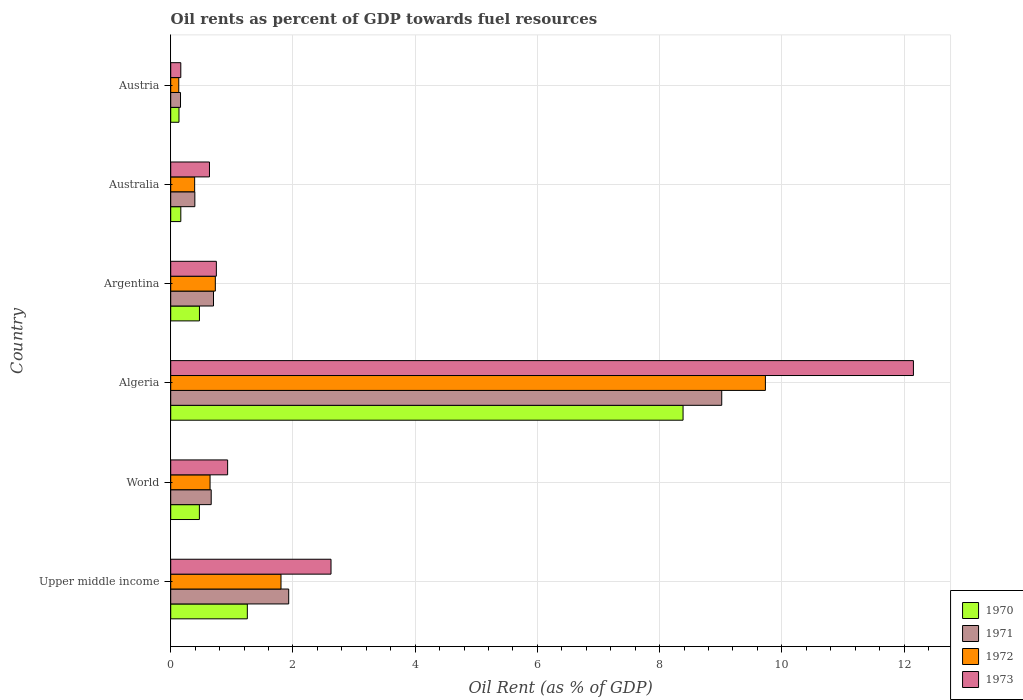Are the number of bars on each tick of the Y-axis equal?
Keep it short and to the point. Yes. How many bars are there on the 2nd tick from the top?
Give a very brief answer. 4. What is the oil rent in 1970 in Australia?
Make the answer very short. 0.17. Across all countries, what is the maximum oil rent in 1971?
Keep it short and to the point. 9.02. Across all countries, what is the minimum oil rent in 1970?
Make the answer very short. 0.14. In which country was the oil rent in 1972 maximum?
Provide a succinct answer. Algeria. What is the total oil rent in 1972 in the graph?
Keep it short and to the point. 13.43. What is the difference between the oil rent in 1972 in Australia and that in World?
Ensure brevity in your answer.  -0.25. What is the difference between the oil rent in 1973 in Upper middle income and the oil rent in 1970 in Algeria?
Make the answer very short. -5.76. What is the average oil rent in 1970 per country?
Provide a short and direct response. 1.81. What is the difference between the oil rent in 1972 and oil rent in 1971 in Upper middle income?
Provide a short and direct response. -0.13. What is the ratio of the oil rent in 1972 in Argentina to that in World?
Give a very brief answer. 1.13. Is the oil rent in 1971 in Algeria less than that in Austria?
Offer a terse response. No. Is the difference between the oil rent in 1972 in Austria and Upper middle income greater than the difference between the oil rent in 1971 in Austria and Upper middle income?
Give a very brief answer. Yes. What is the difference between the highest and the second highest oil rent in 1970?
Offer a terse response. 7.13. What is the difference between the highest and the lowest oil rent in 1970?
Offer a terse response. 8.25. In how many countries, is the oil rent in 1973 greater than the average oil rent in 1973 taken over all countries?
Ensure brevity in your answer.  1. What does the 3rd bar from the top in Australia represents?
Provide a succinct answer. 1971. What does the 1st bar from the bottom in Argentina represents?
Give a very brief answer. 1970. How many bars are there?
Keep it short and to the point. 24. How many countries are there in the graph?
Make the answer very short. 6. What is the difference between two consecutive major ticks on the X-axis?
Ensure brevity in your answer.  2. Does the graph contain grids?
Make the answer very short. Yes. How many legend labels are there?
Provide a succinct answer. 4. How are the legend labels stacked?
Ensure brevity in your answer.  Vertical. What is the title of the graph?
Your answer should be very brief. Oil rents as percent of GDP towards fuel resources. What is the label or title of the X-axis?
Provide a short and direct response. Oil Rent (as % of GDP). What is the Oil Rent (as % of GDP) in 1970 in Upper middle income?
Offer a very short reply. 1.25. What is the Oil Rent (as % of GDP) of 1971 in Upper middle income?
Offer a terse response. 1.93. What is the Oil Rent (as % of GDP) of 1972 in Upper middle income?
Provide a short and direct response. 1.8. What is the Oil Rent (as % of GDP) in 1973 in Upper middle income?
Ensure brevity in your answer.  2.62. What is the Oil Rent (as % of GDP) in 1970 in World?
Make the answer very short. 0.47. What is the Oil Rent (as % of GDP) of 1971 in World?
Offer a very short reply. 0.66. What is the Oil Rent (as % of GDP) in 1972 in World?
Your answer should be very brief. 0.64. What is the Oil Rent (as % of GDP) of 1973 in World?
Offer a terse response. 0.93. What is the Oil Rent (as % of GDP) in 1970 in Algeria?
Ensure brevity in your answer.  8.38. What is the Oil Rent (as % of GDP) of 1971 in Algeria?
Your answer should be very brief. 9.02. What is the Oil Rent (as % of GDP) of 1972 in Algeria?
Keep it short and to the point. 9.73. What is the Oil Rent (as % of GDP) of 1973 in Algeria?
Make the answer very short. 12.15. What is the Oil Rent (as % of GDP) of 1970 in Argentina?
Give a very brief answer. 0.47. What is the Oil Rent (as % of GDP) of 1971 in Argentina?
Ensure brevity in your answer.  0.7. What is the Oil Rent (as % of GDP) of 1972 in Argentina?
Offer a terse response. 0.73. What is the Oil Rent (as % of GDP) in 1973 in Argentina?
Offer a very short reply. 0.75. What is the Oil Rent (as % of GDP) of 1970 in Australia?
Your answer should be very brief. 0.17. What is the Oil Rent (as % of GDP) in 1971 in Australia?
Offer a very short reply. 0.39. What is the Oil Rent (as % of GDP) in 1972 in Australia?
Offer a very short reply. 0.39. What is the Oil Rent (as % of GDP) in 1973 in Australia?
Provide a succinct answer. 0.63. What is the Oil Rent (as % of GDP) of 1970 in Austria?
Offer a terse response. 0.14. What is the Oil Rent (as % of GDP) in 1971 in Austria?
Ensure brevity in your answer.  0.16. What is the Oil Rent (as % of GDP) of 1972 in Austria?
Your answer should be very brief. 0.13. What is the Oil Rent (as % of GDP) of 1973 in Austria?
Your answer should be compact. 0.16. Across all countries, what is the maximum Oil Rent (as % of GDP) in 1970?
Offer a very short reply. 8.38. Across all countries, what is the maximum Oil Rent (as % of GDP) in 1971?
Give a very brief answer. 9.02. Across all countries, what is the maximum Oil Rent (as % of GDP) of 1972?
Offer a terse response. 9.73. Across all countries, what is the maximum Oil Rent (as % of GDP) of 1973?
Your response must be concise. 12.15. Across all countries, what is the minimum Oil Rent (as % of GDP) in 1970?
Provide a succinct answer. 0.14. Across all countries, what is the minimum Oil Rent (as % of GDP) of 1971?
Provide a short and direct response. 0.16. Across all countries, what is the minimum Oil Rent (as % of GDP) in 1972?
Offer a terse response. 0.13. Across all countries, what is the minimum Oil Rent (as % of GDP) of 1973?
Ensure brevity in your answer.  0.16. What is the total Oil Rent (as % of GDP) of 1970 in the graph?
Your answer should be very brief. 10.88. What is the total Oil Rent (as % of GDP) in 1971 in the graph?
Ensure brevity in your answer.  12.86. What is the total Oil Rent (as % of GDP) in 1972 in the graph?
Make the answer very short. 13.43. What is the total Oil Rent (as % of GDP) of 1973 in the graph?
Ensure brevity in your answer.  17.25. What is the difference between the Oil Rent (as % of GDP) of 1970 in Upper middle income and that in World?
Offer a very short reply. 0.78. What is the difference between the Oil Rent (as % of GDP) in 1971 in Upper middle income and that in World?
Provide a short and direct response. 1.27. What is the difference between the Oil Rent (as % of GDP) in 1972 in Upper middle income and that in World?
Your response must be concise. 1.16. What is the difference between the Oil Rent (as % of GDP) in 1973 in Upper middle income and that in World?
Give a very brief answer. 1.69. What is the difference between the Oil Rent (as % of GDP) of 1970 in Upper middle income and that in Algeria?
Make the answer very short. -7.13. What is the difference between the Oil Rent (as % of GDP) in 1971 in Upper middle income and that in Algeria?
Ensure brevity in your answer.  -7.09. What is the difference between the Oil Rent (as % of GDP) in 1972 in Upper middle income and that in Algeria?
Provide a short and direct response. -7.93. What is the difference between the Oil Rent (as % of GDP) of 1973 in Upper middle income and that in Algeria?
Offer a very short reply. -9.53. What is the difference between the Oil Rent (as % of GDP) of 1970 in Upper middle income and that in Argentina?
Provide a succinct answer. 0.78. What is the difference between the Oil Rent (as % of GDP) in 1971 in Upper middle income and that in Argentina?
Your answer should be compact. 1.23. What is the difference between the Oil Rent (as % of GDP) in 1972 in Upper middle income and that in Argentina?
Make the answer very short. 1.07. What is the difference between the Oil Rent (as % of GDP) of 1973 in Upper middle income and that in Argentina?
Keep it short and to the point. 1.88. What is the difference between the Oil Rent (as % of GDP) of 1970 in Upper middle income and that in Australia?
Keep it short and to the point. 1.09. What is the difference between the Oil Rent (as % of GDP) in 1971 in Upper middle income and that in Australia?
Your answer should be very brief. 1.54. What is the difference between the Oil Rent (as % of GDP) in 1972 in Upper middle income and that in Australia?
Your answer should be very brief. 1.41. What is the difference between the Oil Rent (as % of GDP) of 1973 in Upper middle income and that in Australia?
Ensure brevity in your answer.  1.99. What is the difference between the Oil Rent (as % of GDP) in 1970 in Upper middle income and that in Austria?
Keep it short and to the point. 1.12. What is the difference between the Oil Rent (as % of GDP) of 1971 in Upper middle income and that in Austria?
Offer a very short reply. 1.77. What is the difference between the Oil Rent (as % of GDP) of 1972 in Upper middle income and that in Austria?
Your answer should be very brief. 1.67. What is the difference between the Oil Rent (as % of GDP) of 1973 in Upper middle income and that in Austria?
Offer a very short reply. 2.46. What is the difference between the Oil Rent (as % of GDP) of 1970 in World and that in Algeria?
Your answer should be compact. -7.91. What is the difference between the Oil Rent (as % of GDP) of 1971 in World and that in Algeria?
Your response must be concise. -8.35. What is the difference between the Oil Rent (as % of GDP) in 1972 in World and that in Algeria?
Ensure brevity in your answer.  -9.09. What is the difference between the Oil Rent (as % of GDP) of 1973 in World and that in Algeria?
Make the answer very short. -11.22. What is the difference between the Oil Rent (as % of GDP) of 1970 in World and that in Argentina?
Ensure brevity in your answer.  -0. What is the difference between the Oil Rent (as % of GDP) in 1971 in World and that in Argentina?
Provide a succinct answer. -0.04. What is the difference between the Oil Rent (as % of GDP) in 1972 in World and that in Argentina?
Provide a short and direct response. -0.09. What is the difference between the Oil Rent (as % of GDP) of 1973 in World and that in Argentina?
Offer a very short reply. 0.18. What is the difference between the Oil Rent (as % of GDP) of 1970 in World and that in Australia?
Your answer should be very brief. 0.3. What is the difference between the Oil Rent (as % of GDP) of 1971 in World and that in Australia?
Give a very brief answer. 0.27. What is the difference between the Oil Rent (as % of GDP) of 1972 in World and that in Australia?
Your response must be concise. 0.25. What is the difference between the Oil Rent (as % of GDP) of 1973 in World and that in Australia?
Make the answer very short. 0.3. What is the difference between the Oil Rent (as % of GDP) of 1970 in World and that in Austria?
Offer a terse response. 0.33. What is the difference between the Oil Rent (as % of GDP) of 1971 in World and that in Austria?
Ensure brevity in your answer.  0.5. What is the difference between the Oil Rent (as % of GDP) in 1972 in World and that in Austria?
Provide a succinct answer. 0.51. What is the difference between the Oil Rent (as % of GDP) of 1973 in World and that in Austria?
Make the answer very short. 0.77. What is the difference between the Oil Rent (as % of GDP) in 1970 in Algeria and that in Argentina?
Your response must be concise. 7.91. What is the difference between the Oil Rent (as % of GDP) of 1971 in Algeria and that in Argentina?
Provide a succinct answer. 8.32. What is the difference between the Oil Rent (as % of GDP) of 1972 in Algeria and that in Argentina?
Offer a terse response. 9. What is the difference between the Oil Rent (as % of GDP) of 1973 in Algeria and that in Argentina?
Provide a succinct answer. 11.41. What is the difference between the Oil Rent (as % of GDP) in 1970 in Algeria and that in Australia?
Your response must be concise. 8.22. What is the difference between the Oil Rent (as % of GDP) of 1971 in Algeria and that in Australia?
Your answer should be compact. 8.62. What is the difference between the Oil Rent (as % of GDP) in 1972 in Algeria and that in Australia?
Provide a succinct answer. 9.34. What is the difference between the Oil Rent (as % of GDP) of 1973 in Algeria and that in Australia?
Your answer should be compact. 11.52. What is the difference between the Oil Rent (as % of GDP) in 1970 in Algeria and that in Austria?
Your response must be concise. 8.25. What is the difference between the Oil Rent (as % of GDP) in 1971 in Algeria and that in Austria?
Your answer should be very brief. 8.86. What is the difference between the Oil Rent (as % of GDP) of 1972 in Algeria and that in Austria?
Keep it short and to the point. 9.6. What is the difference between the Oil Rent (as % of GDP) of 1973 in Algeria and that in Austria?
Offer a terse response. 11.99. What is the difference between the Oil Rent (as % of GDP) of 1970 in Argentina and that in Australia?
Offer a very short reply. 0.3. What is the difference between the Oil Rent (as % of GDP) of 1971 in Argentina and that in Australia?
Your response must be concise. 0.31. What is the difference between the Oil Rent (as % of GDP) in 1972 in Argentina and that in Australia?
Provide a succinct answer. 0.34. What is the difference between the Oil Rent (as % of GDP) of 1973 in Argentina and that in Australia?
Your answer should be very brief. 0.11. What is the difference between the Oil Rent (as % of GDP) in 1970 in Argentina and that in Austria?
Keep it short and to the point. 0.33. What is the difference between the Oil Rent (as % of GDP) of 1971 in Argentina and that in Austria?
Your answer should be compact. 0.54. What is the difference between the Oil Rent (as % of GDP) in 1972 in Argentina and that in Austria?
Give a very brief answer. 0.6. What is the difference between the Oil Rent (as % of GDP) of 1973 in Argentina and that in Austria?
Your answer should be compact. 0.58. What is the difference between the Oil Rent (as % of GDP) in 1970 in Australia and that in Austria?
Your answer should be very brief. 0.03. What is the difference between the Oil Rent (as % of GDP) of 1971 in Australia and that in Austria?
Your response must be concise. 0.23. What is the difference between the Oil Rent (as % of GDP) in 1972 in Australia and that in Austria?
Make the answer very short. 0.26. What is the difference between the Oil Rent (as % of GDP) in 1973 in Australia and that in Austria?
Give a very brief answer. 0.47. What is the difference between the Oil Rent (as % of GDP) of 1970 in Upper middle income and the Oil Rent (as % of GDP) of 1971 in World?
Provide a succinct answer. 0.59. What is the difference between the Oil Rent (as % of GDP) of 1970 in Upper middle income and the Oil Rent (as % of GDP) of 1972 in World?
Offer a terse response. 0.61. What is the difference between the Oil Rent (as % of GDP) of 1970 in Upper middle income and the Oil Rent (as % of GDP) of 1973 in World?
Your response must be concise. 0.32. What is the difference between the Oil Rent (as % of GDP) in 1971 in Upper middle income and the Oil Rent (as % of GDP) in 1972 in World?
Make the answer very short. 1.29. What is the difference between the Oil Rent (as % of GDP) of 1972 in Upper middle income and the Oil Rent (as % of GDP) of 1973 in World?
Provide a succinct answer. 0.87. What is the difference between the Oil Rent (as % of GDP) of 1970 in Upper middle income and the Oil Rent (as % of GDP) of 1971 in Algeria?
Your response must be concise. -7.76. What is the difference between the Oil Rent (as % of GDP) in 1970 in Upper middle income and the Oil Rent (as % of GDP) in 1972 in Algeria?
Provide a succinct answer. -8.48. What is the difference between the Oil Rent (as % of GDP) in 1970 in Upper middle income and the Oil Rent (as % of GDP) in 1973 in Algeria?
Ensure brevity in your answer.  -10.9. What is the difference between the Oil Rent (as % of GDP) in 1971 in Upper middle income and the Oil Rent (as % of GDP) in 1972 in Algeria?
Provide a short and direct response. -7.8. What is the difference between the Oil Rent (as % of GDP) of 1971 in Upper middle income and the Oil Rent (as % of GDP) of 1973 in Algeria?
Your response must be concise. -10.22. What is the difference between the Oil Rent (as % of GDP) of 1972 in Upper middle income and the Oil Rent (as % of GDP) of 1973 in Algeria?
Your answer should be very brief. -10.35. What is the difference between the Oil Rent (as % of GDP) of 1970 in Upper middle income and the Oil Rent (as % of GDP) of 1971 in Argentina?
Your answer should be compact. 0.55. What is the difference between the Oil Rent (as % of GDP) of 1970 in Upper middle income and the Oil Rent (as % of GDP) of 1972 in Argentina?
Your answer should be very brief. 0.52. What is the difference between the Oil Rent (as % of GDP) in 1970 in Upper middle income and the Oil Rent (as % of GDP) in 1973 in Argentina?
Keep it short and to the point. 0.51. What is the difference between the Oil Rent (as % of GDP) of 1971 in Upper middle income and the Oil Rent (as % of GDP) of 1972 in Argentina?
Your answer should be compact. 1.2. What is the difference between the Oil Rent (as % of GDP) of 1971 in Upper middle income and the Oil Rent (as % of GDP) of 1973 in Argentina?
Make the answer very short. 1.18. What is the difference between the Oil Rent (as % of GDP) of 1972 in Upper middle income and the Oil Rent (as % of GDP) of 1973 in Argentina?
Your response must be concise. 1.06. What is the difference between the Oil Rent (as % of GDP) of 1970 in Upper middle income and the Oil Rent (as % of GDP) of 1971 in Australia?
Make the answer very short. 0.86. What is the difference between the Oil Rent (as % of GDP) in 1970 in Upper middle income and the Oil Rent (as % of GDP) in 1972 in Australia?
Your response must be concise. 0.86. What is the difference between the Oil Rent (as % of GDP) of 1970 in Upper middle income and the Oil Rent (as % of GDP) of 1973 in Australia?
Make the answer very short. 0.62. What is the difference between the Oil Rent (as % of GDP) in 1971 in Upper middle income and the Oil Rent (as % of GDP) in 1972 in Australia?
Keep it short and to the point. 1.54. What is the difference between the Oil Rent (as % of GDP) of 1971 in Upper middle income and the Oil Rent (as % of GDP) of 1973 in Australia?
Offer a terse response. 1.3. What is the difference between the Oil Rent (as % of GDP) in 1972 in Upper middle income and the Oil Rent (as % of GDP) in 1973 in Australia?
Offer a very short reply. 1.17. What is the difference between the Oil Rent (as % of GDP) in 1970 in Upper middle income and the Oil Rent (as % of GDP) in 1971 in Austria?
Give a very brief answer. 1.09. What is the difference between the Oil Rent (as % of GDP) of 1970 in Upper middle income and the Oil Rent (as % of GDP) of 1972 in Austria?
Provide a short and direct response. 1.12. What is the difference between the Oil Rent (as % of GDP) in 1970 in Upper middle income and the Oil Rent (as % of GDP) in 1973 in Austria?
Offer a very short reply. 1.09. What is the difference between the Oil Rent (as % of GDP) in 1971 in Upper middle income and the Oil Rent (as % of GDP) in 1972 in Austria?
Your answer should be compact. 1.8. What is the difference between the Oil Rent (as % of GDP) in 1971 in Upper middle income and the Oil Rent (as % of GDP) in 1973 in Austria?
Provide a short and direct response. 1.77. What is the difference between the Oil Rent (as % of GDP) in 1972 in Upper middle income and the Oil Rent (as % of GDP) in 1973 in Austria?
Your answer should be very brief. 1.64. What is the difference between the Oil Rent (as % of GDP) in 1970 in World and the Oil Rent (as % of GDP) in 1971 in Algeria?
Provide a short and direct response. -8.55. What is the difference between the Oil Rent (as % of GDP) of 1970 in World and the Oil Rent (as % of GDP) of 1972 in Algeria?
Provide a short and direct response. -9.26. What is the difference between the Oil Rent (as % of GDP) of 1970 in World and the Oil Rent (as % of GDP) of 1973 in Algeria?
Offer a very short reply. -11.68. What is the difference between the Oil Rent (as % of GDP) in 1971 in World and the Oil Rent (as % of GDP) in 1972 in Algeria?
Ensure brevity in your answer.  -9.07. What is the difference between the Oil Rent (as % of GDP) in 1971 in World and the Oil Rent (as % of GDP) in 1973 in Algeria?
Ensure brevity in your answer.  -11.49. What is the difference between the Oil Rent (as % of GDP) of 1972 in World and the Oil Rent (as % of GDP) of 1973 in Algeria?
Your response must be concise. -11.51. What is the difference between the Oil Rent (as % of GDP) of 1970 in World and the Oil Rent (as % of GDP) of 1971 in Argentina?
Offer a very short reply. -0.23. What is the difference between the Oil Rent (as % of GDP) of 1970 in World and the Oil Rent (as % of GDP) of 1972 in Argentina?
Offer a terse response. -0.26. What is the difference between the Oil Rent (as % of GDP) of 1970 in World and the Oil Rent (as % of GDP) of 1973 in Argentina?
Provide a succinct answer. -0.28. What is the difference between the Oil Rent (as % of GDP) of 1971 in World and the Oil Rent (as % of GDP) of 1972 in Argentina?
Provide a succinct answer. -0.07. What is the difference between the Oil Rent (as % of GDP) in 1971 in World and the Oil Rent (as % of GDP) in 1973 in Argentina?
Offer a very short reply. -0.08. What is the difference between the Oil Rent (as % of GDP) in 1972 in World and the Oil Rent (as % of GDP) in 1973 in Argentina?
Your response must be concise. -0.1. What is the difference between the Oil Rent (as % of GDP) of 1970 in World and the Oil Rent (as % of GDP) of 1971 in Australia?
Ensure brevity in your answer.  0.07. What is the difference between the Oil Rent (as % of GDP) of 1970 in World and the Oil Rent (as % of GDP) of 1972 in Australia?
Offer a very short reply. 0.08. What is the difference between the Oil Rent (as % of GDP) in 1970 in World and the Oil Rent (as % of GDP) in 1973 in Australia?
Make the answer very short. -0.17. What is the difference between the Oil Rent (as % of GDP) of 1971 in World and the Oil Rent (as % of GDP) of 1972 in Australia?
Make the answer very short. 0.27. What is the difference between the Oil Rent (as % of GDP) in 1971 in World and the Oil Rent (as % of GDP) in 1973 in Australia?
Provide a succinct answer. 0.03. What is the difference between the Oil Rent (as % of GDP) of 1972 in World and the Oil Rent (as % of GDP) of 1973 in Australia?
Keep it short and to the point. 0.01. What is the difference between the Oil Rent (as % of GDP) of 1970 in World and the Oil Rent (as % of GDP) of 1971 in Austria?
Keep it short and to the point. 0.31. What is the difference between the Oil Rent (as % of GDP) of 1970 in World and the Oil Rent (as % of GDP) of 1972 in Austria?
Your answer should be very brief. 0.34. What is the difference between the Oil Rent (as % of GDP) of 1970 in World and the Oil Rent (as % of GDP) of 1973 in Austria?
Your answer should be compact. 0.3. What is the difference between the Oil Rent (as % of GDP) in 1971 in World and the Oil Rent (as % of GDP) in 1972 in Austria?
Your answer should be very brief. 0.53. What is the difference between the Oil Rent (as % of GDP) of 1971 in World and the Oil Rent (as % of GDP) of 1973 in Austria?
Give a very brief answer. 0.5. What is the difference between the Oil Rent (as % of GDP) in 1972 in World and the Oil Rent (as % of GDP) in 1973 in Austria?
Your response must be concise. 0.48. What is the difference between the Oil Rent (as % of GDP) of 1970 in Algeria and the Oil Rent (as % of GDP) of 1971 in Argentina?
Your answer should be compact. 7.68. What is the difference between the Oil Rent (as % of GDP) of 1970 in Algeria and the Oil Rent (as % of GDP) of 1972 in Argentina?
Your answer should be compact. 7.65. What is the difference between the Oil Rent (as % of GDP) in 1970 in Algeria and the Oil Rent (as % of GDP) in 1973 in Argentina?
Your response must be concise. 7.64. What is the difference between the Oil Rent (as % of GDP) in 1971 in Algeria and the Oil Rent (as % of GDP) in 1972 in Argentina?
Provide a short and direct response. 8.29. What is the difference between the Oil Rent (as % of GDP) in 1971 in Algeria and the Oil Rent (as % of GDP) in 1973 in Argentina?
Your answer should be very brief. 8.27. What is the difference between the Oil Rent (as % of GDP) of 1972 in Algeria and the Oil Rent (as % of GDP) of 1973 in Argentina?
Give a very brief answer. 8.98. What is the difference between the Oil Rent (as % of GDP) in 1970 in Algeria and the Oil Rent (as % of GDP) in 1971 in Australia?
Your answer should be compact. 7.99. What is the difference between the Oil Rent (as % of GDP) in 1970 in Algeria and the Oil Rent (as % of GDP) in 1972 in Australia?
Your answer should be very brief. 7.99. What is the difference between the Oil Rent (as % of GDP) in 1970 in Algeria and the Oil Rent (as % of GDP) in 1973 in Australia?
Keep it short and to the point. 7.75. What is the difference between the Oil Rent (as % of GDP) in 1971 in Algeria and the Oil Rent (as % of GDP) in 1972 in Australia?
Ensure brevity in your answer.  8.62. What is the difference between the Oil Rent (as % of GDP) in 1971 in Algeria and the Oil Rent (as % of GDP) in 1973 in Australia?
Give a very brief answer. 8.38. What is the difference between the Oil Rent (as % of GDP) in 1972 in Algeria and the Oil Rent (as % of GDP) in 1973 in Australia?
Your answer should be compact. 9.1. What is the difference between the Oil Rent (as % of GDP) of 1970 in Algeria and the Oil Rent (as % of GDP) of 1971 in Austria?
Provide a short and direct response. 8.22. What is the difference between the Oil Rent (as % of GDP) of 1970 in Algeria and the Oil Rent (as % of GDP) of 1972 in Austria?
Your answer should be compact. 8.25. What is the difference between the Oil Rent (as % of GDP) of 1970 in Algeria and the Oil Rent (as % of GDP) of 1973 in Austria?
Offer a very short reply. 8.22. What is the difference between the Oil Rent (as % of GDP) of 1971 in Algeria and the Oil Rent (as % of GDP) of 1972 in Austria?
Offer a terse response. 8.88. What is the difference between the Oil Rent (as % of GDP) in 1971 in Algeria and the Oil Rent (as % of GDP) in 1973 in Austria?
Make the answer very short. 8.85. What is the difference between the Oil Rent (as % of GDP) in 1972 in Algeria and the Oil Rent (as % of GDP) in 1973 in Austria?
Give a very brief answer. 9.57. What is the difference between the Oil Rent (as % of GDP) of 1970 in Argentina and the Oil Rent (as % of GDP) of 1971 in Australia?
Make the answer very short. 0.08. What is the difference between the Oil Rent (as % of GDP) in 1970 in Argentina and the Oil Rent (as % of GDP) in 1972 in Australia?
Make the answer very short. 0.08. What is the difference between the Oil Rent (as % of GDP) of 1970 in Argentina and the Oil Rent (as % of GDP) of 1973 in Australia?
Keep it short and to the point. -0.16. What is the difference between the Oil Rent (as % of GDP) of 1971 in Argentina and the Oil Rent (as % of GDP) of 1972 in Australia?
Make the answer very short. 0.31. What is the difference between the Oil Rent (as % of GDP) of 1971 in Argentina and the Oil Rent (as % of GDP) of 1973 in Australia?
Offer a terse response. 0.07. What is the difference between the Oil Rent (as % of GDP) in 1972 in Argentina and the Oil Rent (as % of GDP) in 1973 in Australia?
Provide a succinct answer. 0.1. What is the difference between the Oil Rent (as % of GDP) in 1970 in Argentina and the Oil Rent (as % of GDP) in 1971 in Austria?
Your response must be concise. 0.31. What is the difference between the Oil Rent (as % of GDP) in 1970 in Argentina and the Oil Rent (as % of GDP) in 1972 in Austria?
Give a very brief answer. 0.34. What is the difference between the Oil Rent (as % of GDP) of 1970 in Argentina and the Oil Rent (as % of GDP) of 1973 in Austria?
Provide a short and direct response. 0.31. What is the difference between the Oil Rent (as % of GDP) in 1971 in Argentina and the Oil Rent (as % of GDP) in 1972 in Austria?
Offer a very short reply. 0.57. What is the difference between the Oil Rent (as % of GDP) in 1971 in Argentina and the Oil Rent (as % of GDP) in 1973 in Austria?
Your answer should be compact. 0.54. What is the difference between the Oil Rent (as % of GDP) in 1972 in Argentina and the Oil Rent (as % of GDP) in 1973 in Austria?
Provide a succinct answer. 0.57. What is the difference between the Oil Rent (as % of GDP) of 1970 in Australia and the Oil Rent (as % of GDP) of 1971 in Austria?
Offer a terse response. 0. What is the difference between the Oil Rent (as % of GDP) in 1970 in Australia and the Oil Rent (as % of GDP) in 1972 in Austria?
Ensure brevity in your answer.  0.03. What is the difference between the Oil Rent (as % of GDP) of 1970 in Australia and the Oil Rent (as % of GDP) of 1973 in Austria?
Your answer should be compact. 0. What is the difference between the Oil Rent (as % of GDP) of 1971 in Australia and the Oil Rent (as % of GDP) of 1972 in Austria?
Provide a short and direct response. 0.26. What is the difference between the Oil Rent (as % of GDP) in 1971 in Australia and the Oil Rent (as % of GDP) in 1973 in Austria?
Keep it short and to the point. 0.23. What is the difference between the Oil Rent (as % of GDP) in 1972 in Australia and the Oil Rent (as % of GDP) in 1973 in Austria?
Offer a terse response. 0.23. What is the average Oil Rent (as % of GDP) of 1970 per country?
Your answer should be very brief. 1.81. What is the average Oil Rent (as % of GDP) in 1971 per country?
Ensure brevity in your answer.  2.14. What is the average Oil Rent (as % of GDP) in 1972 per country?
Offer a terse response. 2.24. What is the average Oil Rent (as % of GDP) of 1973 per country?
Ensure brevity in your answer.  2.88. What is the difference between the Oil Rent (as % of GDP) in 1970 and Oil Rent (as % of GDP) in 1971 in Upper middle income?
Keep it short and to the point. -0.68. What is the difference between the Oil Rent (as % of GDP) in 1970 and Oil Rent (as % of GDP) in 1972 in Upper middle income?
Ensure brevity in your answer.  -0.55. What is the difference between the Oil Rent (as % of GDP) in 1970 and Oil Rent (as % of GDP) in 1973 in Upper middle income?
Make the answer very short. -1.37. What is the difference between the Oil Rent (as % of GDP) in 1971 and Oil Rent (as % of GDP) in 1972 in Upper middle income?
Ensure brevity in your answer.  0.13. What is the difference between the Oil Rent (as % of GDP) in 1971 and Oil Rent (as % of GDP) in 1973 in Upper middle income?
Ensure brevity in your answer.  -0.69. What is the difference between the Oil Rent (as % of GDP) in 1972 and Oil Rent (as % of GDP) in 1973 in Upper middle income?
Keep it short and to the point. -0.82. What is the difference between the Oil Rent (as % of GDP) of 1970 and Oil Rent (as % of GDP) of 1971 in World?
Provide a short and direct response. -0.19. What is the difference between the Oil Rent (as % of GDP) of 1970 and Oil Rent (as % of GDP) of 1972 in World?
Your answer should be compact. -0.17. What is the difference between the Oil Rent (as % of GDP) of 1970 and Oil Rent (as % of GDP) of 1973 in World?
Give a very brief answer. -0.46. What is the difference between the Oil Rent (as % of GDP) in 1971 and Oil Rent (as % of GDP) in 1972 in World?
Keep it short and to the point. 0.02. What is the difference between the Oil Rent (as % of GDP) in 1971 and Oil Rent (as % of GDP) in 1973 in World?
Provide a short and direct response. -0.27. What is the difference between the Oil Rent (as % of GDP) of 1972 and Oil Rent (as % of GDP) of 1973 in World?
Your answer should be very brief. -0.29. What is the difference between the Oil Rent (as % of GDP) in 1970 and Oil Rent (as % of GDP) in 1971 in Algeria?
Give a very brief answer. -0.63. What is the difference between the Oil Rent (as % of GDP) of 1970 and Oil Rent (as % of GDP) of 1972 in Algeria?
Provide a short and direct response. -1.35. What is the difference between the Oil Rent (as % of GDP) in 1970 and Oil Rent (as % of GDP) in 1973 in Algeria?
Offer a terse response. -3.77. What is the difference between the Oil Rent (as % of GDP) in 1971 and Oil Rent (as % of GDP) in 1972 in Algeria?
Your response must be concise. -0.71. What is the difference between the Oil Rent (as % of GDP) in 1971 and Oil Rent (as % of GDP) in 1973 in Algeria?
Make the answer very short. -3.14. What is the difference between the Oil Rent (as % of GDP) of 1972 and Oil Rent (as % of GDP) of 1973 in Algeria?
Offer a terse response. -2.42. What is the difference between the Oil Rent (as % of GDP) in 1970 and Oil Rent (as % of GDP) in 1971 in Argentina?
Your answer should be compact. -0.23. What is the difference between the Oil Rent (as % of GDP) in 1970 and Oil Rent (as % of GDP) in 1972 in Argentina?
Keep it short and to the point. -0.26. What is the difference between the Oil Rent (as % of GDP) of 1970 and Oil Rent (as % of GDP) of 1973 in Argentina?
Keep it short and to the point. -0.28. What is the difference between the Oil Rent (as % of GDP) of 1971 and Oil Rent (as % of GDP) of 1972 in Argentina?
Provide a short and direct response. -0.03. What is the difference between the Oil Rent (as % of GDP) of 1971 and Oil Rent (as % of GDP) of 1973 in Argentina?
Offer a terse response. -0.05. What is the difference between the Oil Rent (as % of GDP) of 1972 and Oil Rent (as % of GDP) of 1973 in Argentina?
Provide a succinct answer. -0.02. What is the difference between the Oil Rent (as % of GDP) of 1970 and Oil Rent (as % of GDP) of 1971 in Australia?
Make the answer very short. -0.23. What is the difference between the Oil Rent (as % of GDP) in 1970 and Oil Rent (as % of GDP) in 1972 in Australia?
Provide a short and direct response. -0.23. What is the difference between the Oil Rent (as % of GDP) of 1970 and Oil Rent (as % of GDP) of 1973 in Australia?
Provide a succinct answer. -0.47. What is the difference between the Oil Rent (as % of GDP) of 1971 and Oil Rent (as % of GDP) of 1972 in Australia?
Your response must be concise. 0. What is the difference between the Oil Rent (as % of GDP) of 1971 and Oil Rent (as % of GDP) of 1973 in Australia?
Your answer should be very brief. -0.24. What is the difference between the Oil Rent (as % of GDP) in 1972 and Oil Rent (as % of GDP) in 1973 in Australia?
Provide a short and direct response. -0.24. What is the difference between the Oil Rent (as % of GDP) of 1970 and Oil Rent (as % of GDP) of 1971 in Austria?
Your answer should be very brief. -0.03. What is the difference between the Oil Rent (as % of GDP) in 1970 and Oil Rent (as % of GDP) in 1972 in Austria?
Provide a succinct answer. 0. What is the difference between the Oil Rent (as % of GDP) in 1970 and Oil Rent (as % of GDP) in 1973 in Austria?
Make the answer very short. -0.03. What is the difference between the Oil Rent (as % of GDP) of 1971 and Oil Rent (as % of GDP) of 1972 in Austria?
Offer a very short reply. 0.03. What is the difference between the Oil Rent (as % of GDP) in 1971 and Oil Rent (as % of GDP) in 1973 in Austria?
Give a very brief answer. -0. What is the difference between the Oil Rent (as % of GDP) in 1972 and Oil Rent (as % of GDP) in 1973 in Austria?
Your answer should be compact. -0.03. What is the ratio of the Oil Rent (as % of GDP) in 1970 in Upper middle income to that in World?
Provide a succinct answer. 2.67. What is the ratio of the Oil Rent (as % of GDP) in 1971 in Upper middle income to that in World?
Offer a terse response. 2.91. What is the ratio of the Oil Rent (as % of GDP) of 1972 in Upper middle income to that in World?
Offer a terse response. 2.8. What is the ratio of the Oil Rent (as % of GDP) in 1973 in Upper middle income to that in World?
Offer a very short reply. 2.82. What is the ratio of the Oil Rent (as % of GDP) in 1970 in Upper middle income to that in Algeria?
Offer a terse response. 0.15. What is the ratio of the Oil Rent (as % of GDP) in 1971 in Upper middle income to that in Algeria?
Your answer should be very brief. 0.21. What is the ratio of the Oil Rent (as % of GDP) in 1972 in Upper middle income to that in Algeria?
Your answer should be compact. 0.19. What is the ratio of the Oil Rent (as % of GDP) of 1973 in Upper middle income to that in Algeria?
Offer a very short reply. 0.22. What is the ratio of the Oil Rent (as % of GDP) of 1970 in Upper middle income to that in Argentina?
Your answer should be very brief. 2.67. What is the ratio of the Oil Rent (as % of GDP) in 1971 in Upper middle income to that in Argentina?
Provide a short and direct response. 2.76. What is the ratio of the Oil Rent (as % of GDP) of 1972 in Upper middle income to that in Argentina?
Your response must be concise. 2.47. What is the ratio of the Oil Rent (as % of GDP) of 1973 in Upper middle income to that in Argentina?
Provide a succinct answer. 3.51. What is the ratio of the Oil Rent (as % of GDP) in 1970 in Upper middle income to that in Australia?
Ensure brevity in your answer.  7.58. What is the ratio of the Oil Rent (as % of GDP) of 1971 in Upper middle income to that in Australia?
Keep it short and to the point. 4.89. What is the ratio of the Oil Rent (as % of GDP) in 1972 in Upper middle income to that in Australia?
Keep it short and to the point. 4.61. What is the ratio of the Oil Rent (as % of GDP) in 1973 in Upper middle income to that in Australia?
Make the answer very short. 4.14. What is the ratio of the Oil Rent (as % of GDP) in 1970 in Upper middle income to that in Austria?
Provide a succinct answer. 9.26. What is the ratio of the Oil Rent (as % of GDP) in 1971 in Upper middle income to that in Austria?
Offer a terse response. 12.04. What is the ratio of the Oil Rent (as % of GDP) of 1972 in Upper middle income to that in Austria?
Offer a terse response. 13.7. What is the ratio of the Oil Rent (as % of GDP) in 1973 in Upper middle income to that in Austria?
Make the answer very short. 15.9. What is the ratio of the Oil Rent (as % of GDP) in 1970 in World to that in Algeria?
Give a very brief answer. 0.06. What is the ratio of the Oil Rent (as % of GDP) in 1971 in World to that in Algeria?
Make the answer very short. 0.07. What is the ratio of the Oil Rent (as % of GDP) of 1972 in World to that in Algeria?
Offer a terse response. 0.07. What is the ratio of the Oil Rent (as % of GDP) of 1973 in World to that in Algeria?
Make the answer very short. 0.08. What is the ratio of the Oil Rent (as % of GDP) of 1970 in World to that in Argentina?
Give a very brief answer. 1. What is the ratio of the Oil Rent (as % of GDP) of 1971 in World to that in Argentina?
Provide a short and direct response. 0.95. What is the ratio of the Oil Rent (as % of GDP) of 1972 in World to that in Argentina?
Give a very brief answer. 0.88. What is the ratio of the Oil Rent (as % of GDP) in 1973 in World to that in Argentina?
Offer a terse response. 1.25. What is the ratio of the Oil Rent (as % of GDP) in 1970 in World to that in Australia?
Offer a terse response. 2.84. What is the ratio of the Oil Rent (as % of GDP) of 1971 in World to that in Australia?
Keep it short and to the point. 1.68. What is the ratio of the Oil Rent (as % of GDP) in 1972 in World to that in Australia?
Your answer should be compact. 1.64. What is the ratio of the Oil Rent (as % of GDP) of 1973 in World to that in Australia?
Offer a terse response. 1.47. What is the ratio of the Oil Rent (as % of GDP) of 1970 in World to that in Austria?
Your answer should be very brief. 3.47. What is the ratio of the Oil Rent (as % of GDP) in 1971 in World to that in Austria?
Offer a terse response. 4.13. What is the ratio of the Oil Rent (as % of GDP) in 1972 in World to that in Austria?
Your answer should be compact. 4.89. What is the ratio of the Oil Rent (as % of GDP) in 1973 in World to that in Austria?
Your answer should be very brief. 5.65. What is the ratio of the Oil Rent (as % of GDP) in 1970 in Algeria to that in Argentina?
Give a very brief answer. 17.83. What is the ratio of the Oil Rent (as % of GDP) in 1971 in Algeria to that in Argentina?
Offer a very short reply. 12.88. What is the ratio of the Oil Rent (as % of GDP) of 1972 in Algeria to that in Argentina?
Provide a succinct answer. 13.33. What is the ratio of the Oil Rent (as % of GDP) in 1973 in Algeria to that in Argentina?
Offer a terse response. 16.27. What is the ratio of the Oil Rent (as % of GDP) of 1970 in Algeria to that in Australia?
Offer a terse response. 50.73. What is the ratio of the Oil Rent (as % of GDP) in 1971 in Algeria to that in Australia?
Give a very brief answer. 22.84. What is the ratio of the Oil Rent (as % of GDP) in 1972 in Algeria to that in Australia?
Offer a terse response. 24.84. What is the ratio of the Oil Rent (as % of GDP) in 1973 in Algeria to that in Australia?
Keep it short and to the point. 19.16. What is the ratio of the Oil Rent (as % of GDP) of 1970 in Algeria to that in Austria?
Give a very brief answer. 61.94. What is the ratio of the Oil Rent (as % of GDP) in 1971 in Algeria to that in Austria?
Your answer should be compact. 56.22. What is the ratio of the Oil Rent (as % of GDP) in 1972 in Algeria to that in Austria?
Give a very brief answer. 73.89. What is the ratio of the Oil Rent (as % of GDP) in 1973 in Algeria to that in Austria?
Offer a terse response. 73.69. What is the ratio of the Oil Rent (as % of GDP) of 1970 in Argentina to that in Australia?
Keep it short and to the point. 2.85. What is the ratio of the Oil Rent (as % of GDP) of 1971 in Argentina to that in Australia?
Provide a short and direct response. 1.77. What is the ratio of the Oil Rent (as % of GDP) in 1972 in Argentina to that in Australia?
Ensure brevity in your answer.  1.86. What is the ratio of the Oil Rent (as % of GDP) of 1973 in Argentina to that in Australia?
Offer a very short reply. 1.18. What is the ratio of the Oil Rent (as % of GDP) of 1970 in Argentina to that in Austria?
Keep it short and to the point. 3.47. What is the ratio of the Oil Rent (as % of GDP) in 1971 in Argentina to that in Austria?
Offer a very short reply. 4.36. What is the ratio of the Oil Rent (as % of GDP) of 1972 in Argentina to that in Austria?
Provide a succinct answer. 5.54. What is the ratio of the Oil Rent (as % of GDP) in 1973 in Argentina to that in Austria?
Offer a terse response. 4.53. What is the ratio of the Oil Rent (as % of GDP) of 1970 in Australia to that in Austria?
Ensure brevity in your answer.  1.22. What is the ratio of the Oil Rent (as % of GDP) in 1971 in Australia to that in Austria?
Make the answer very short. 2.46. What is the ratio of the Oil Rent (as % of GDP) of 1972 in Australia to that in Austria?
Give a very brief answer. 2.97. What is the ratio of the Oil Rent (as % of GDP) in 1973 in Australia to that in Austria?
Ensure brevity in your answer.  3.85. What is the difference between the highest and the second highest Oil Rent (as % of GDP) of 1970?
Provide a succinct answer. 7.13. What is the difference between the highest and the second highest Oil Rent (as % of GDP) in 1971?
Keep it short and to the point. 7.09. What is the difference between the highest and the second highest Oil Rent (as % of GDP) in 1972?
Your answer should be very brief. 7.93. What is the difference between the highest and the second highest Oil Rent (as % of GDP) in 1973?
Ensure brevity in your answer.  9.53. What is the difference between the highest and the lowest Oil Rent (as % of GDP) in 1970?
Your answer should be very brief. 8.25. What is the difference between the highest and the lowest Oil Rent (as % of GDP) of 1971?
Provide a short and direct response. 8.86. What is the difference between the highest and the lowest Oil Rent (as % of GDP) of 1972?
Your response must be concise. 9.6. What is the difference between the highest and the lowest Oil Rent (as % of GDP) of 1973?
Offer a terse response. 11.99. 